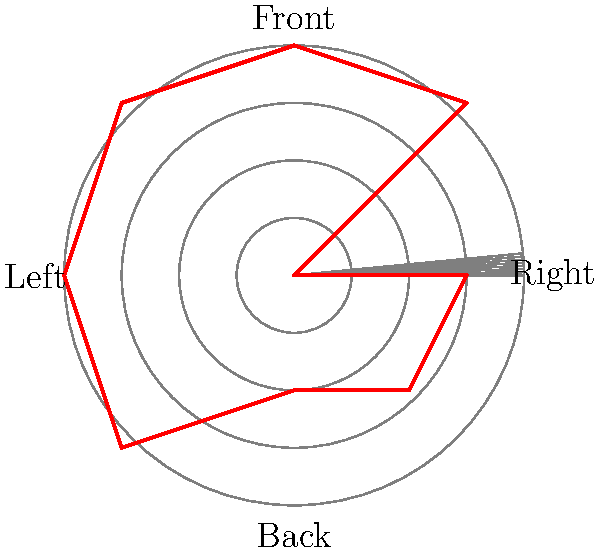Based on the polar grid representation of footwork patterns during a taekwondo match, which direction shows the most frequent and extensive movements? To answer this question, we need to analyze the red line representing the footwork pattern on the polar grid:

1. The grid is divided into 8 directions, with the front, back, left, and right clearly labeled.
2. The concentric circles represent the extent of movement, with outer circles indicating more extensive movements.
3. Examine the red line in each direction:
   - Front: Reaches the 4th circle
   - Front-Right: Reaches between the 2nd and 3rd circle
   - Right: Reaches the 3rd circle
   - Back-Right: Reaches the 2nd circle
   - Back: Reaches the 2nd circle
   - Back-Left: Reaches the 3rd circle
   - Left: Reaches the 4th circle
   - Front-Left: Reaches the 3rd circle
4. The directions reaching the outermost (4th) circle are the front and left.
5. Between these two, the left side shows a longer continuous line along the 4th circle.

Therefore, the left direction shows the most frequent and extensive movements during this taekwondo match.
Answer: Left 